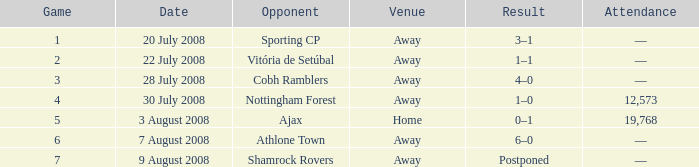What is the result on 20 July 2008? 3–1. 